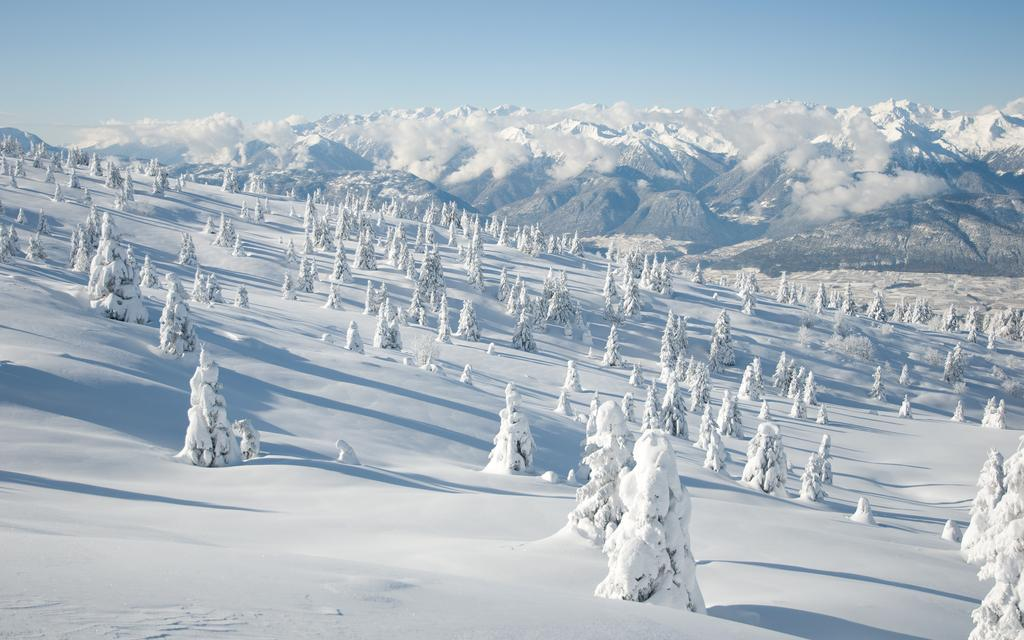What type of natural features can be seen in the image? There are trees and mountains in the image. What part of the sky is visible in the image? The sky is visible in the image. What type of location was the image taken in? The image was taken near ice mountains. At what time of day was the image taken? The image was taken during the day. What color crayon is being used to draw on the seashore in the image? There is no seashore or crayon present in the image. What type of music is the band playing in the background of the image? There is no band or music present in the image. 